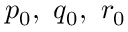Convert formula to latex. <formula><loc_0><loc_0><loc_500><loc_500>p _ { 0 } , q _ { 0 } , r _ { 0 }</formula> 